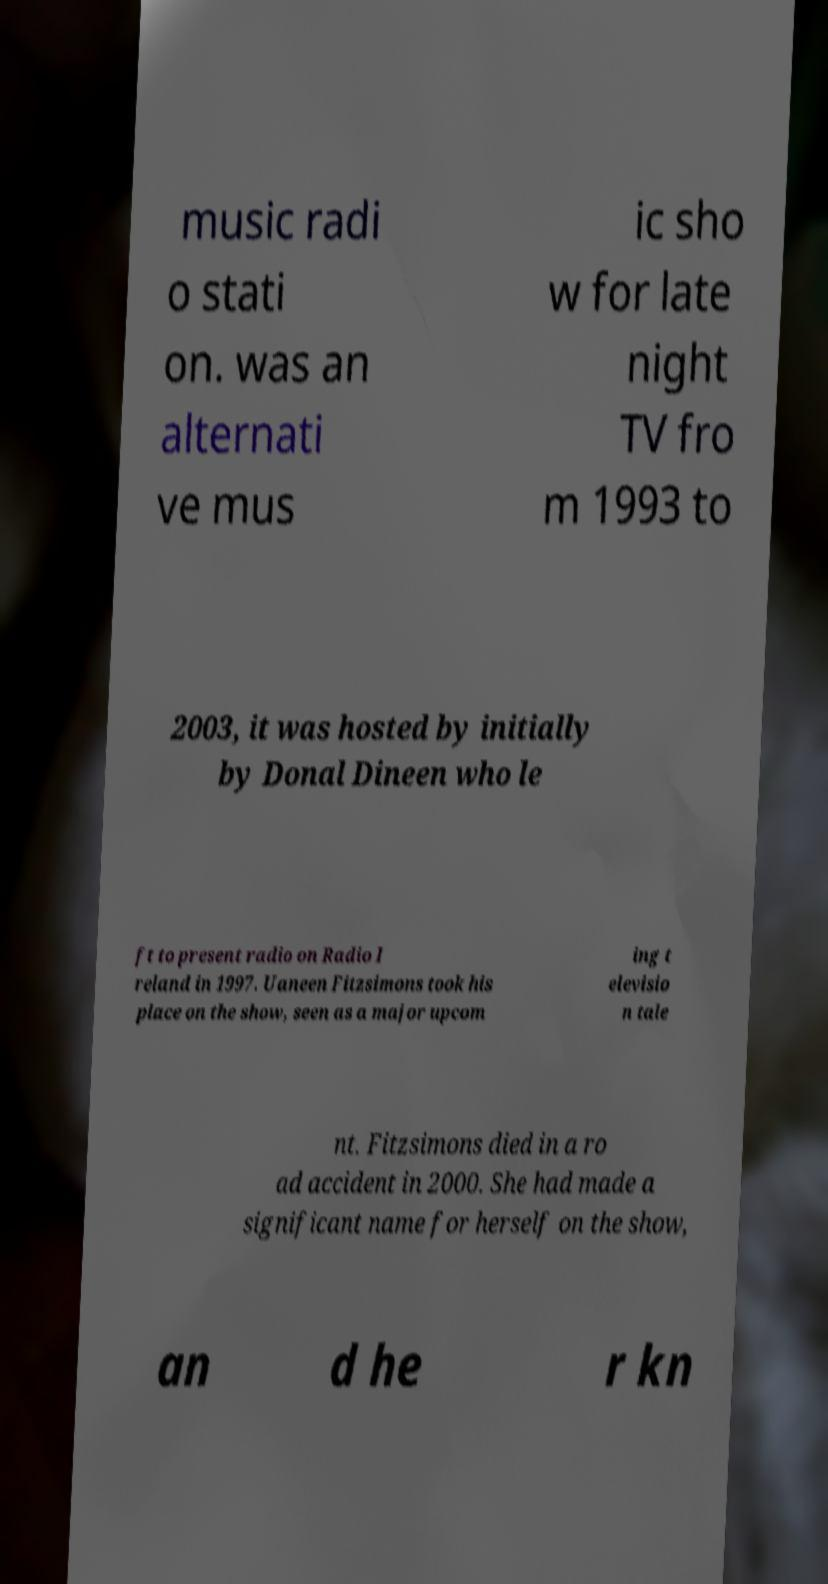What messages or text are displayed in this image? I need them in a readable, typed format. music radi o stati on. was an alternati ve mus ic sho w for late night TV fro m 1993 to 2003, it was hosted by initially by Donal Dineen who le ft to present radio on Radio I reland in 1997. Uaneen Fitzsimons took his place on the show, seen as a major upcom ing t elevisio n tale nt. Fitzsimons died in a ro ad accident in 2000. She had made a significant name for herself on the show, an d he r kn 